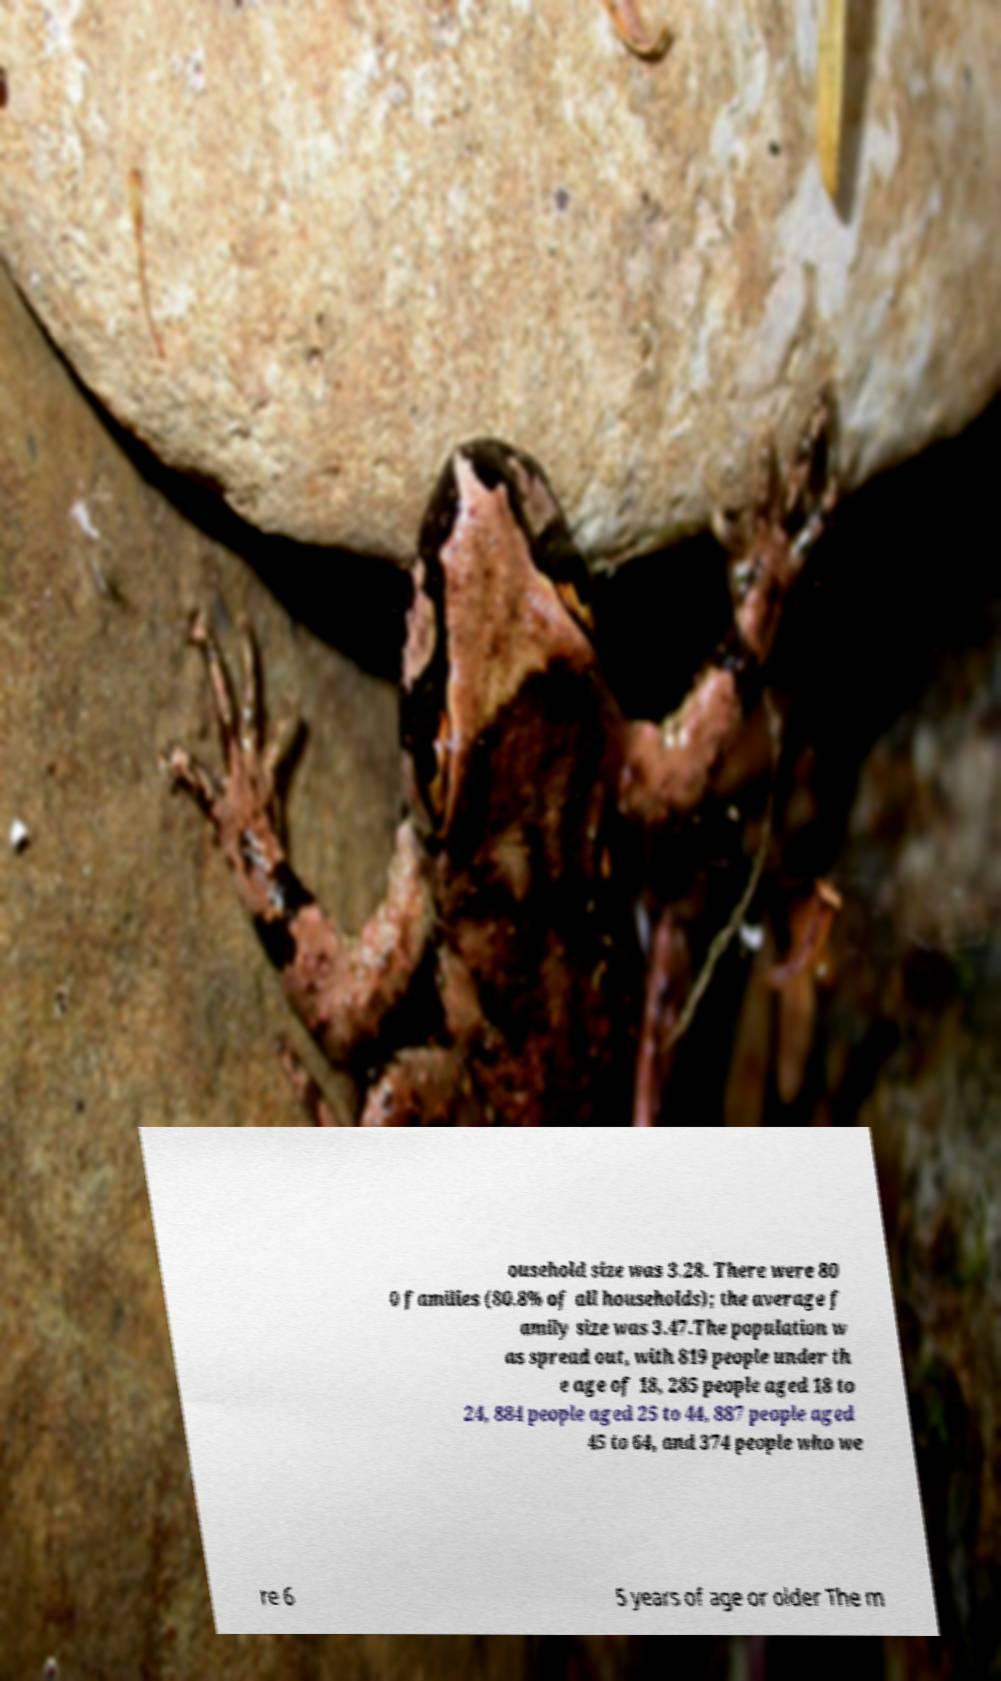What messages or text are displayed in this image? I need them in a readable, typed format. ousehold size was 3.28. There were 80 0 families (80.8% of all households); the average f amily size was 3.47.The population w as spread out, with 819 people under th e age of 18, 285 people aged 18 to 24, 884 people aged 25 to 44, 887 people aged 45 to 64, and 374 people who we re 6 5 years of age or older The m 